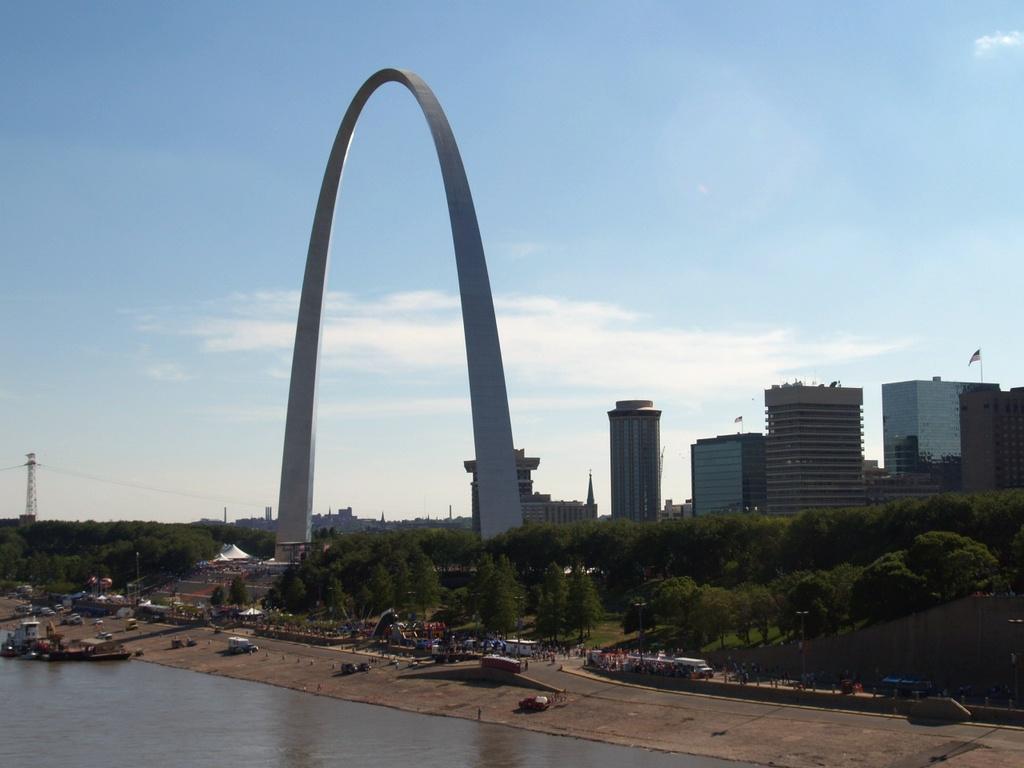Please provide a concise description of this image. At the bottom of the image there is water. Also there are boats. And there are many vehicles and people. In the back there are trees and an arch. Also there are buildings and sky with clouds. On the left side there is a tower. 